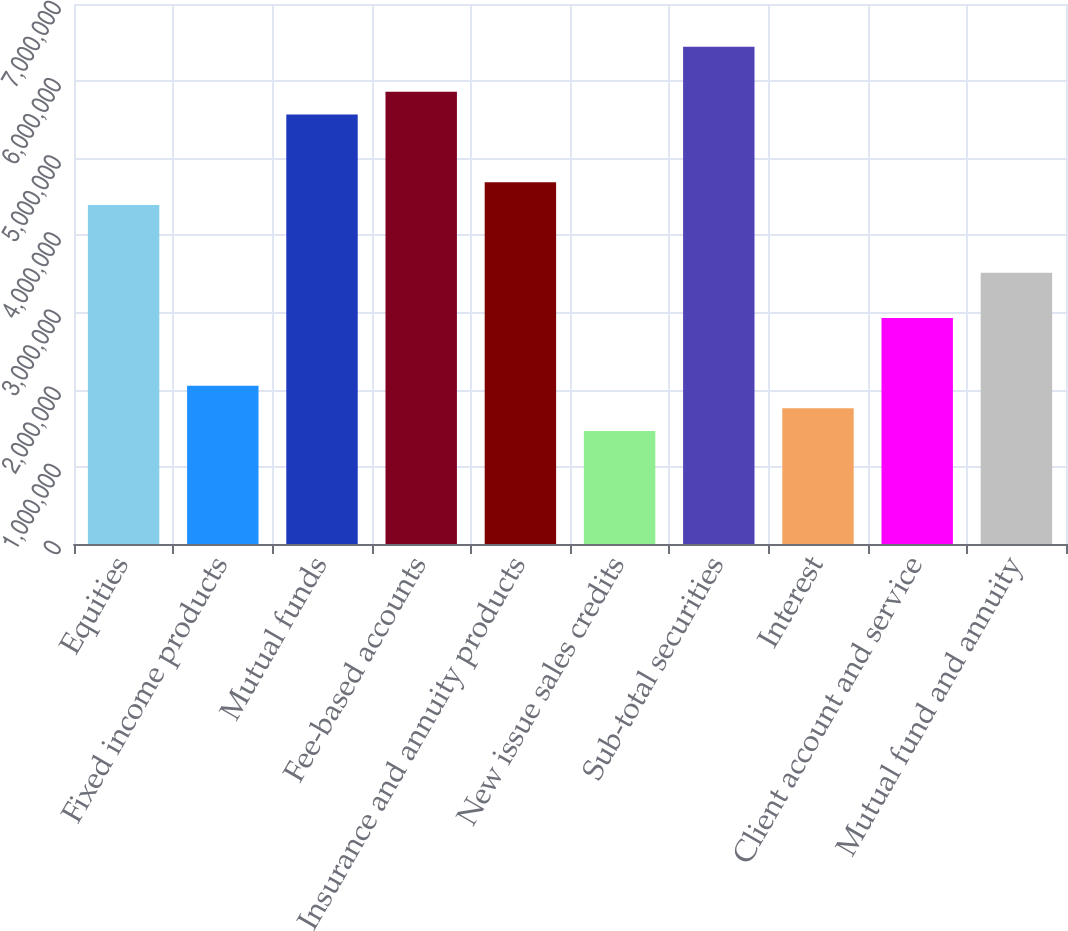Convert chart to OTSL. <chart><loc_0><loc_0><loc_500><loc_500><bar_chart><fcel>Equities<fcel>Fixed income products<fcel>Mutual funds<fcel>Fee-based accounts<fcel>Insurance and annuity products<fcel>New issue sales credits<fcel>Sub-total securities<fcel>Interest<fcel>Client account and service<fcel>Mutual fund and annuity<nl><fcel>4.39576e+06<fcel>2.05151e+06<fcel>5.56789e+06<fcel>5.86092e+06<fcel>4.6888e+06<fcel>1.46544e+06<fcel>6.44699e+06<fcel>1.75847e+06<fcel>2.9306e+06<fcel>3.51667e+06<nl></chart> 